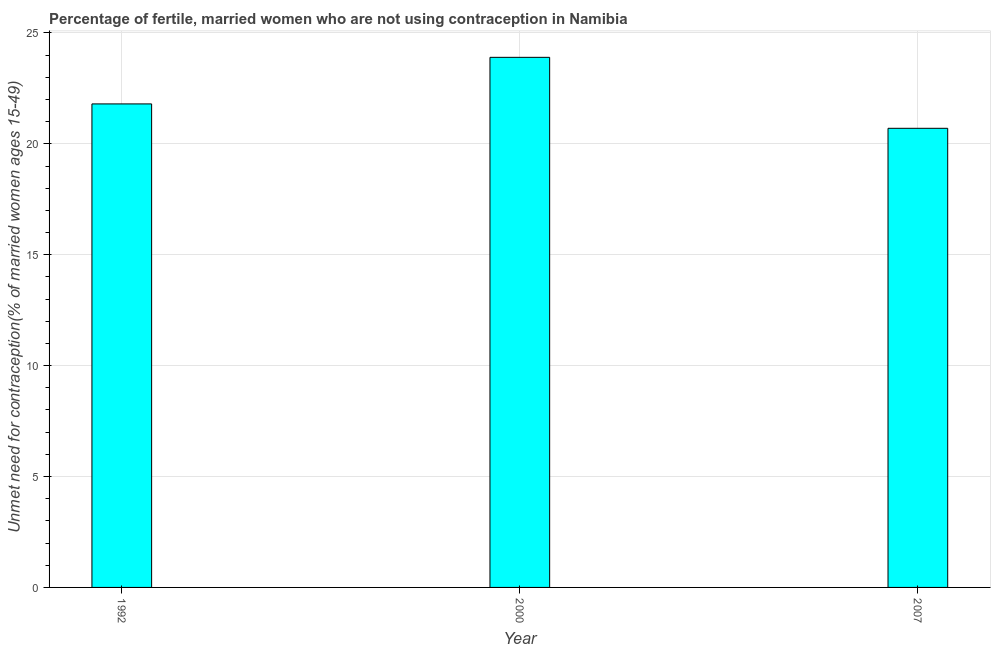Does the graph contain any zero values?
Your response must be concise. No. What is the title of the graph?
Offer a very short reply. Percentage of fertile, married women who are not using contraception in Namibia. What is the label or title of the X-axis?
Provide a short and direct response. Year. What is the label or title of the Y-axis?
Your response must be concise.  Unmet need for contraception(% of married women ages 15-49). What is the number of married women who are not using contraception in 1992?
Offer a terse response. 21.8. Across all years, what is the maximum number of married women who are not using contraception?
Offer a very short reply. 23.9. Across all years, what is the minimum number of married women who are not using contraception?
Provide a succinct answer. 20.7. In which year was the number of married women who are not using contraception maximum?
Make the answer very short. 2000. In which year was the number of married women who are not using contraception minimum?
Provide a short and direct response. 2007. What is the sum of the number of married women who are not using contraception?
Your answer should be very brief. 66.4. What is the average number of married women who are not using contraception per year?
Your response must be concise. 22.13. What is the median number of married women who are not using contraception?
Your answer should be very brief. 21.8. In how many years, is the number of married women who are not using contraception greater than 21 %?
Keep it short and to the point. 2. Do a majority of the years between 2000 and 2007 (inclusive) have number of married women who are not using contraception greater than 16 %?
Offer a very short reply. Yes. What is the ratio of the number of married women who are not using contraception in 2000 to that in 2007?
Your response must be concise. 1.16. Is the number of married women who are not using contraception in 1992 less than that in 2007?
Give a very brief answer. No. What is the difference between the highest and the lowest number of married women who are not using contraception?
Provide a succinct answer. 3.2. Are all the bars in the graph horizontal?
Provide a short and direct response. No. How many years are there in the graph?
Your answer should be very brief. 3. Are the values on the major ticks of Y-axis written in scientific E-notation?
Offer a terse response. No. What is the  Unmet need for contraception(% of married women ages 15-49) of 1992?
Ensure brevity in your answer.  21.8. What is the  Unmet need for contraception(% of married women ages 15-49) of 2000?
Ensure brevity in your answer.  23.9. What is the  Unmet need for contraception(% of married women ages 15-49) in 2007?
Provide a succinct answer. 20.7. What is the difference between the  Unmet need for contraception(% of married women ages 15-49) in 1992 and 2007?
Offer a very short reply. 1.1. What is the difference between the  Unmet need for contraception(% of married women ages 15-49) in 2000 and 2007?
Your answer should be compact. 3.2. What is the ratio of the  Unmet need for contraception(% of married women ages 15-49) in 1992 to that in 2000?
Ensure brevity in your answer.  0.91. What is the ratio of the  Unmet need for contraception(% of married women ages 15-49) in 1992 to that in 2007?
Your answer should be compact. 1.05. What is the ratio of the  Unmet need for contraception(% of married women ages 15-49) in 2000 to that in 2007?
Your response must be concise. 1.16. 